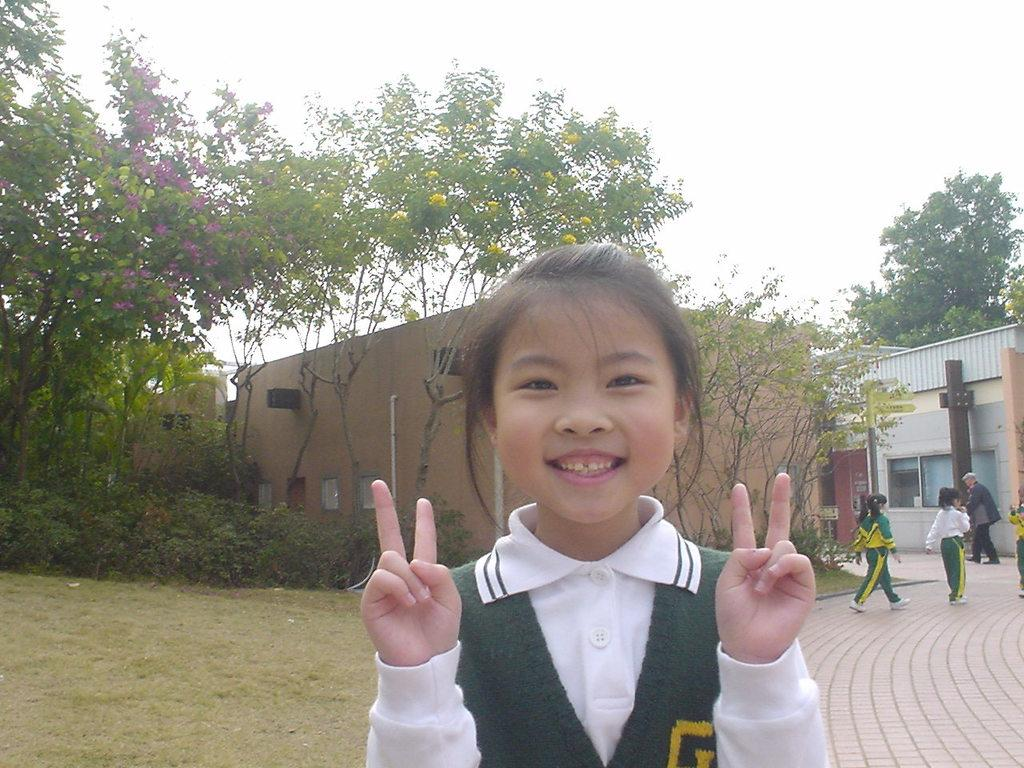How many people are present in the image? There are people in the image, but the exact number is not specified. What type of natural environment is visible in the people are in? The image features grass, plants, trees, and flowers, indicating a natural environment. What type of structures can be seen in the image? There are houses in the image. Are there any man-made objects visible in the image? Yes, there are pipelines in the image. What color are the eyes of the person in the image? There is no information about the color of anyone's eyes in the image. How much glue is needed to fix the broken pipeline in the image? There is no indication of a broken pipeline or the need for glue in the image. 